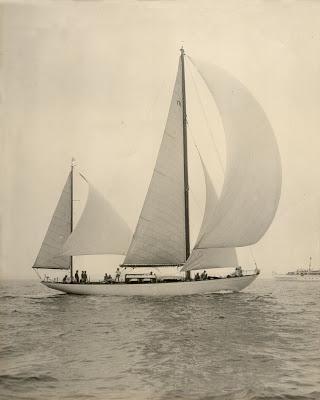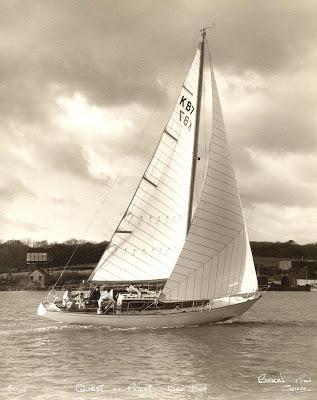The first image is the image on the left, the second image is the image on the right. Considering the images on both sides, is "The left image shows a sailboat with a small triangle sail on the left and a nearly flat horizon and a non-blue sky." valid? Answer yes or no. Yes. The first image is the image on the left, the second image is the image on the right. For the images displayed, is the sentence "In the image to the left, the boat has more than four sails unfurled." factually correct? Answer yes or no. Yes. 